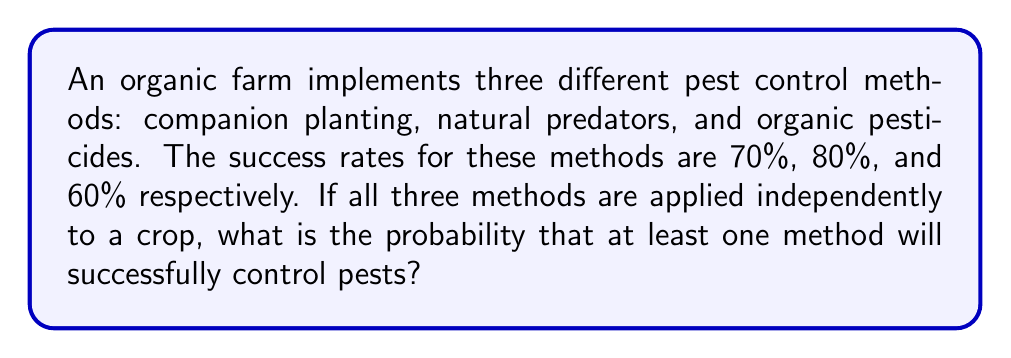Can you answer this question? Let's approach this step-by-step:

1) First, we need to understand that we're looking for the probability of at least one method being successful. It's often easier to calculate this by finding the probability of all methods failing and subtracting it from 1.

2) Let's define our events:
   A: Companion planting succeeds
   B: Natural predators succeed
   C: Organic pesticides succeed

3) We're given the following probabilities:
   P(A) = 0.70
   P(B) = 0.80
   P(C) = 0.60

4) The probability of each method failing is:
   P(not A) = 1 - P(A) = 1 - 0.70 = 0.30
   P(not B) = 1 - P(B) = 1 - 0.80 = 0.20
   P(not C) = 1 - P(C) = 1 - 0.60 = 0.40

5) Since the methods are applied independently, we can multiply these probabilities to find the probability of all methods failing:

   P(all fail) = P(not A) × P(not B) × P(not C)
               = 0.30 × 0.20 × 0.40
               = 0.024

6) Therefore, the probability of at least one method succeeding is:

   P(at least one succeeds) = 1 - P(all fail)
                            = 1 - 0.024
                            = 0.976

7) We can express this as a percentage: 0.976 × 100% = 97.6%
Answer: $0.976$ or $97.6\%$ 